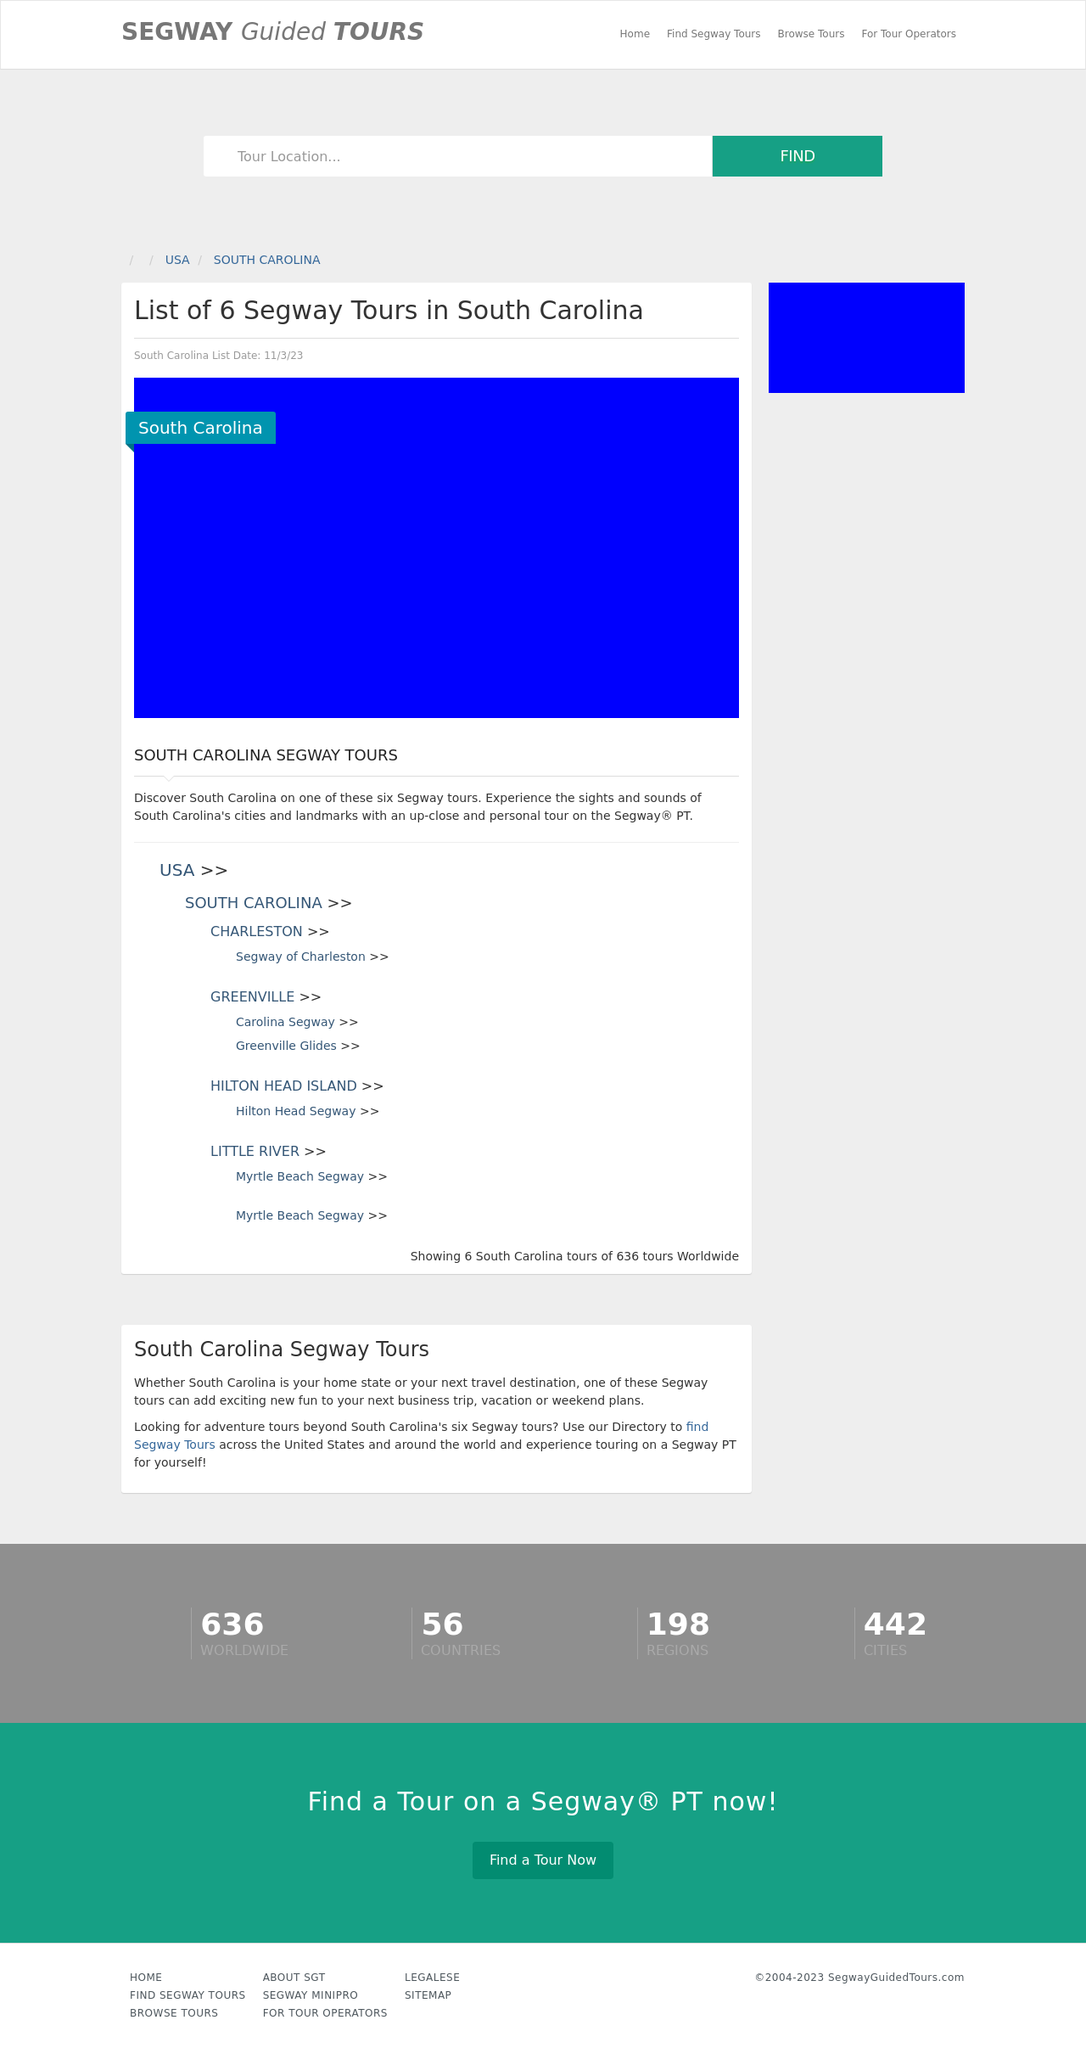Can you explain which key landmarks in South Carolina might be included in these Segway tours? The Segway tours in South Carolina likely include key landmarks such as the historic areas of Charleston, the scenic paths of Greenville, the coastal beauty of Hilton Head Island, and the vibrant waterfront settings of cities like Myrtle Beach. Each city offers a unique array of sights, from historic buildings and district areas to natural parks and riversides. 